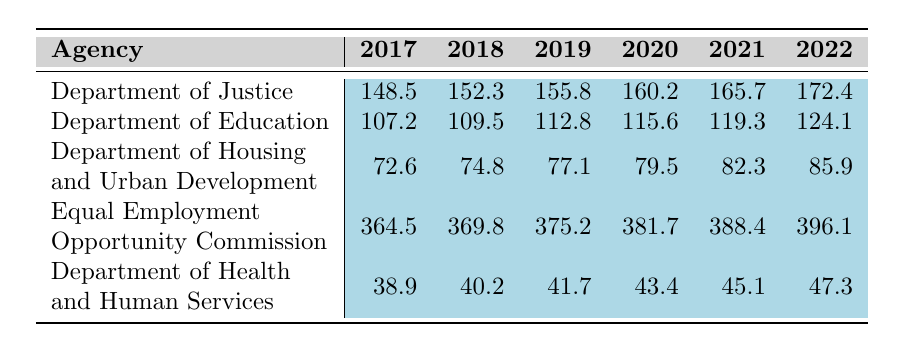What was the funding amount for the Equal Employment Opportunity Commission in 2022? Referring to the table, the funding amount for the Equal Employment Opportunity Commission in 2022 is listed directly in the corresponding cell. The value is 396.1.
Answer: 396.1 Which agency received the highest funding in 2019? By looking at the 2019 column in the table, the funding amounts are Department of Justice (155.8), Department of Education (112.8), Department of Housing and Urban Development (77.1), Equal Employment Opportunity Commission (375.2), and Department of Health and Human Services (41.7). The highest amount is from the Equal Employment Opportunity Commission at 375.2.
Answer: Equal Employment Opportunity Commission What was the total funding for the Department of Health and Human Services from 2017 to 2022? Summing the values for the Department of Health and Human Services over the fiscal years 2017 (38.9), 2018 (40.2), 2019 (41.7), 2020 (43.4), 2021 (45.1), and 2022 (47.3) gives us (38.9 + 40.2 + 41.7 + 43.4 + 45.1 + 47.3) = 256.6.
Answer: 256.6 What is the difference in funding for the Department of Justice between 2017 and 2022? The funding amounts for the Department of Justice in 2017 is 148.5 and in 2022 is 172.4. The difference is calculated by subtracting 2017's funding from 2022's, which is (172.4 - 148.5) = 23.9.
Answer: 23.9 Did the funding for the Department of Housing and Urban Development increase every year from 2017 to 2022? Examining the funding amounts for the Department of Housing and Urban Development for each year shows: 72.6, 74.8, 77.1, 79.5, 82.3, and 85.9. Each subsequent year shows an increase, confirming that the funding did increase every year.
Answer: Yes What is the average funding amount for the Department of Education from 2017 to 2022? The total funding amounts for the Department of Education are: 107.2, 109.5, 112.8, 115.6, 119.3, and 124.1. Adding these gives (107.2 + 109.5 + 112.8 + 115.6 + 119.3 + 124.1) = 788.5. To find the average, divide by the number of years (6), yielding 788.5 / 6 = 131.4167, which rounds to 131.42.
Answer: 131.42 What fiscal year saw the largest single-year increase in funding for the Equal Employment Opportunity Commission? Calculating the year-over-year increases from the table: (369.8 - 364.5), (375.2 - 369.8), (381.7 - 375.2), (388.4 - 381.7), and (396.1 - 388.4) results in differences of 5.3, 5.4, 6.5, 6.7, and 7.7 respectively. The largest increase is from 2021 to 2022 (7.7).
Answer: 2021 to 2022 Which agency showed the smallest funding increase between any two consecutive fiscal years? To determine this, we will find the annual increases for each agency. For example, for the Department of Justice: (152.3 - 148.5) = 3.8, (155.8 - 152.3) = 3.5, and so on. By comparing all year-on-year increases for all agencies, we find that the smallest increase is 1.1 (Department of Health and Human Services from 2018 to 2019).
Answer: Department of Health and Human Services What trend can be observed in the funding for the Department of Justice from 2017 to 2022? The values for the Department of Justice show a consistent increase each year: 148.5, 152.3, 155.8, 160.2, 165.7, and 172.4. This trend indicates a steady rise in funding over the years.
Answer: Steady increase 